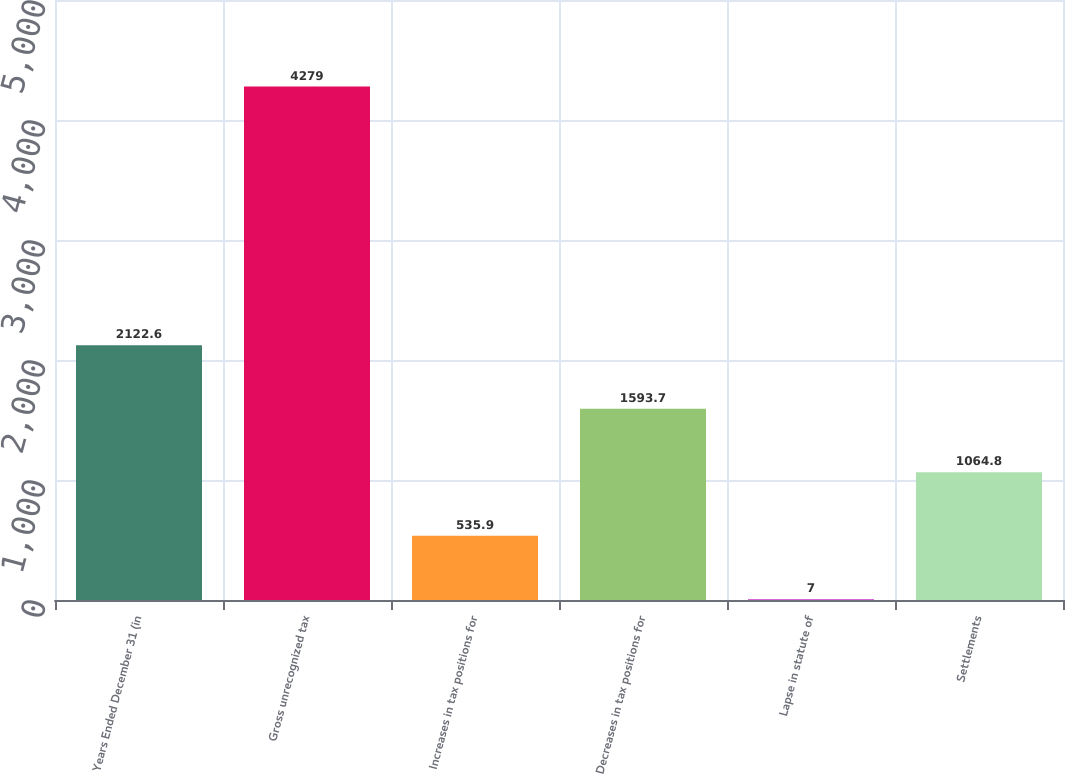<chart> <loc_0><loc_0><loc_500><loc_500><bar_chart><fcel>Years Ended December 31 (in<fcel>Gross unrecognized tax<fcel>Increases in tax positions for<fcel>Decreases in tax positions for<fcel>Lapse in statute of<fcel>Settlements<nl><fcel>2122.6<fcel>4279<fcel>535.9<fcel>1593.7<fcel>7<fcel>1064.8<nl></chart> 